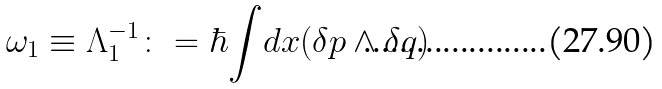<formula> <loc_0><loc_0><loc_500><loc_500>\omega _ { 1 } \equiv \Lambda _ { 1 } ^ { - 1 } \colon = \hbar { \int } d x ( \delta p \wedge \delta q )</formula> 